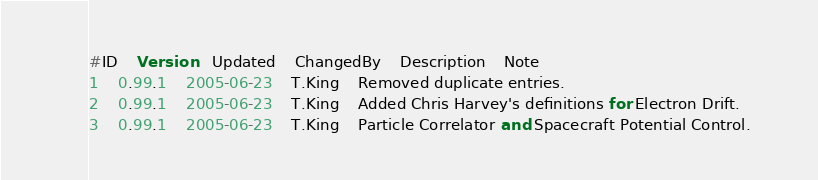<code> <loc_0><loc_0><loc_500><loc_500><_SQL_>#ID	Version	Updated	ChangedBy	Description	Note
1	0.99.1	2005-06-23	T.King	Removed duplicate entries.	
2	0.99.1	2005-06-23	T.King	Added Chris Harvey's definitions for Electron Drift.	
3	0.99.1	2005-06-23	T.King	Particle Correlator and Spacecraft Potential Control.	</code> 